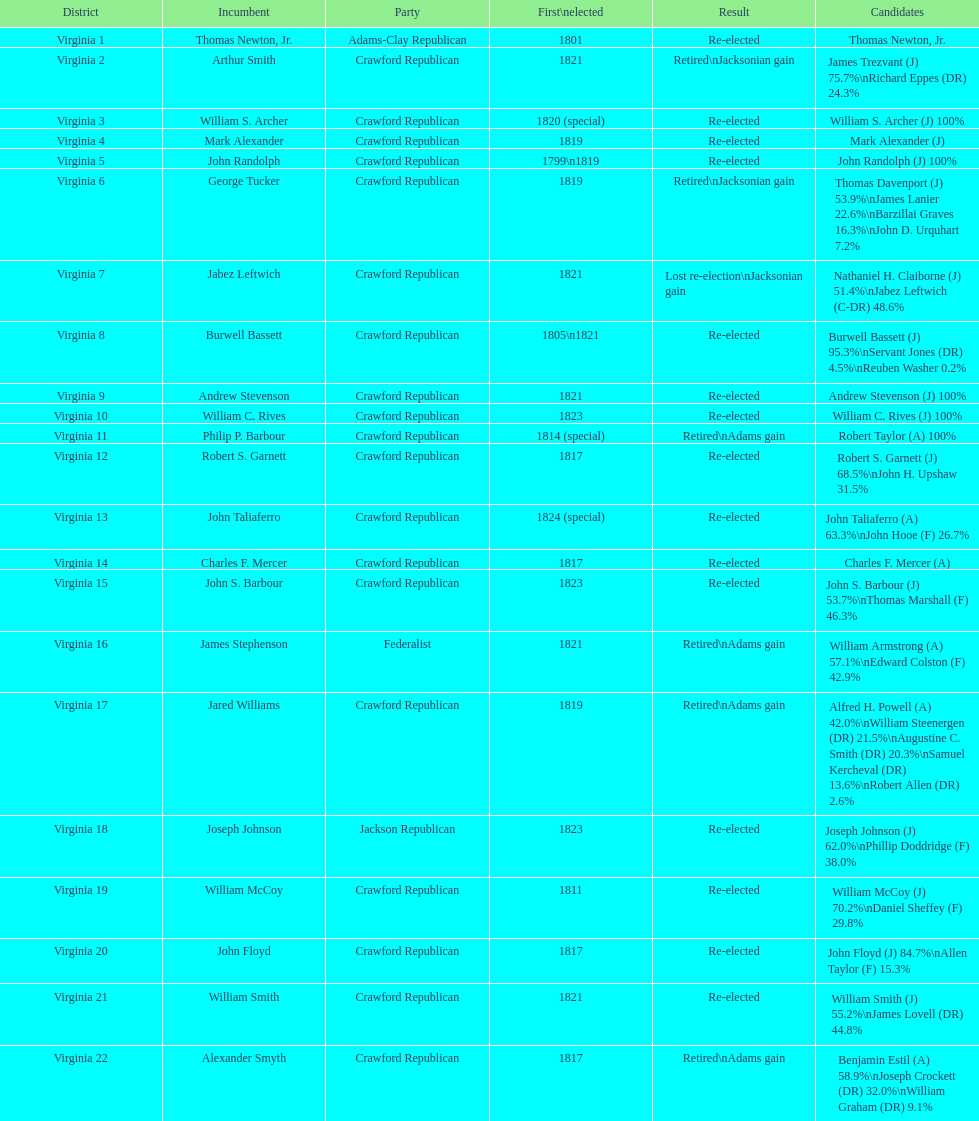How many districts are there in virginia? 22. 